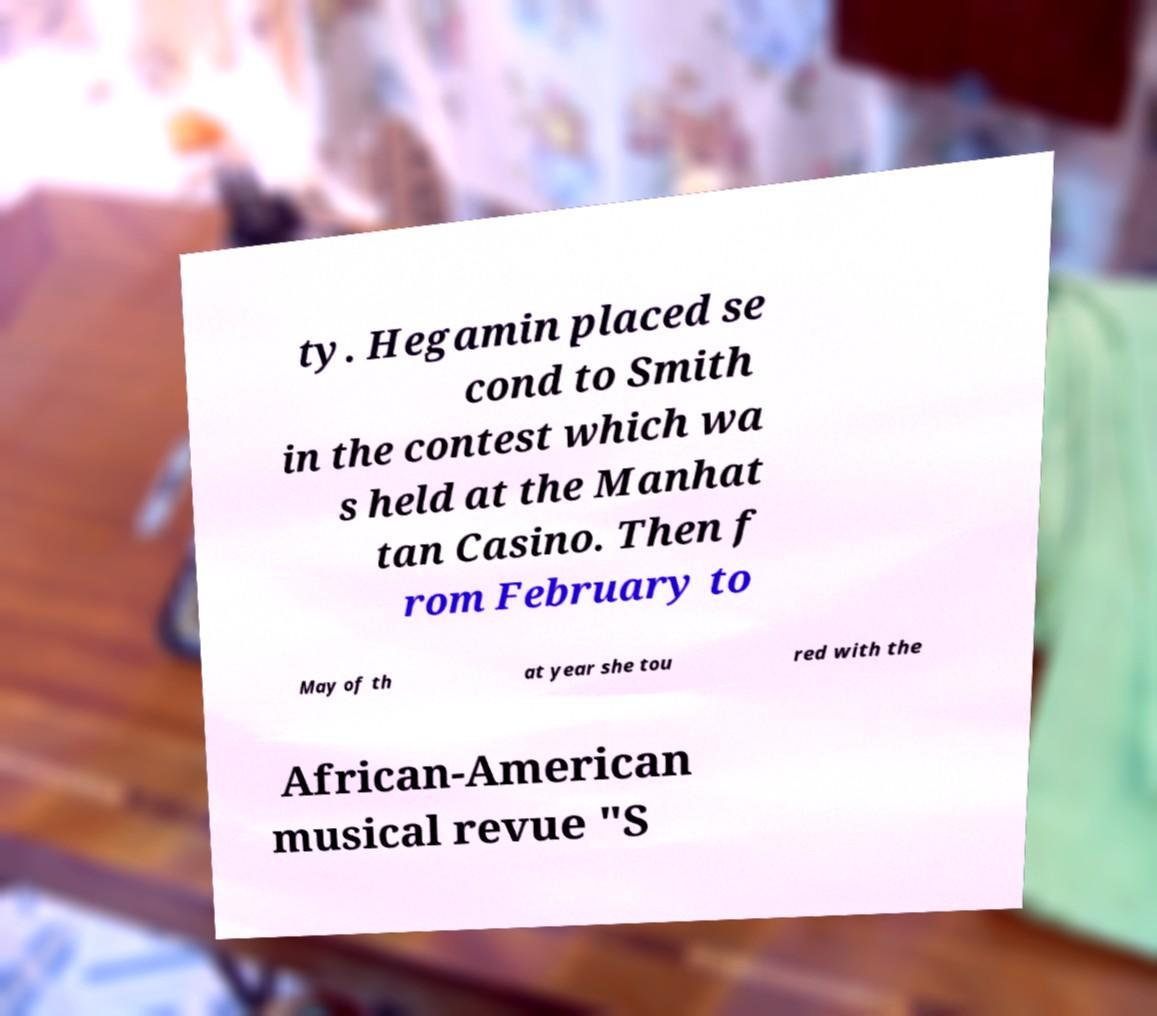Please identify and transcribe the text found in this image. ty. Hegamin placed se cond to Smith in the contest which wa s held at the Manhat tan Casino. Then f rom February to May of th at year she tou red with the African-American musical revue "S 